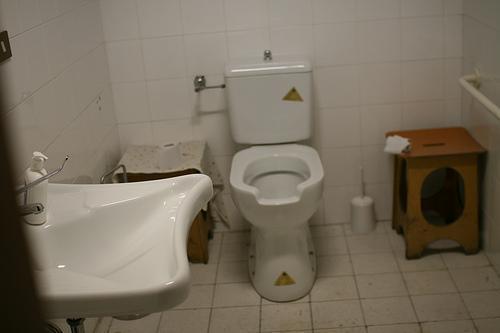How many toilets?
Give a very brief answer. 1. How many tables?
Give a very brief answer. 2. 